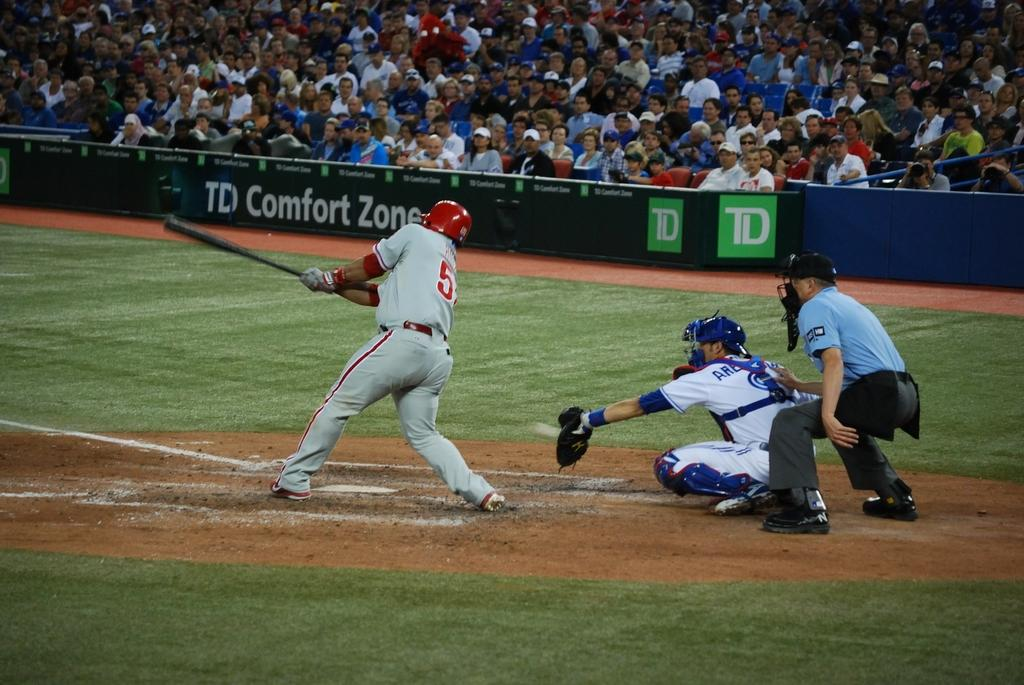Provide a one-sentence caption for the provided image. A man with a five on the back of his jersey is batting. 